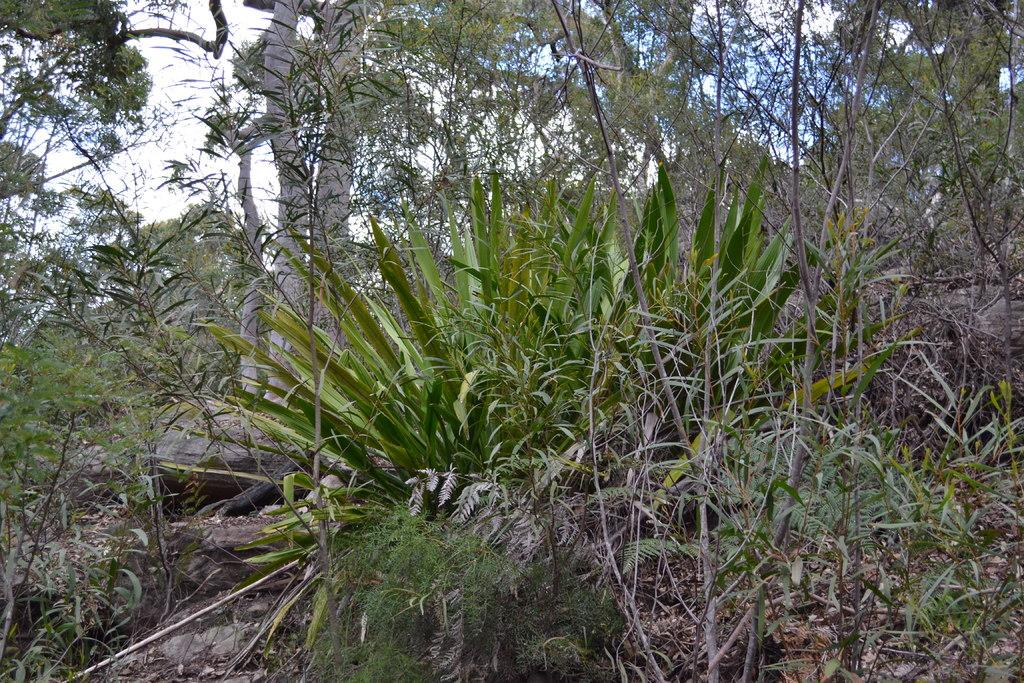What types of vegetation can be seen in the image? The image contains plants and trees. What part of the natural environment is visible in the image? The sky is visible at the top of the image, and the ground is visible at the bottom of the image. What can be found on the ground in the image? Dried leaves are present on the ground. How many passengers are visible in the image? There are no passengers present in the image; it features plants, trees, and the natural environment. Can you tell me which snails are reciting a verse in the image? There are no snails or verses present in the image. 